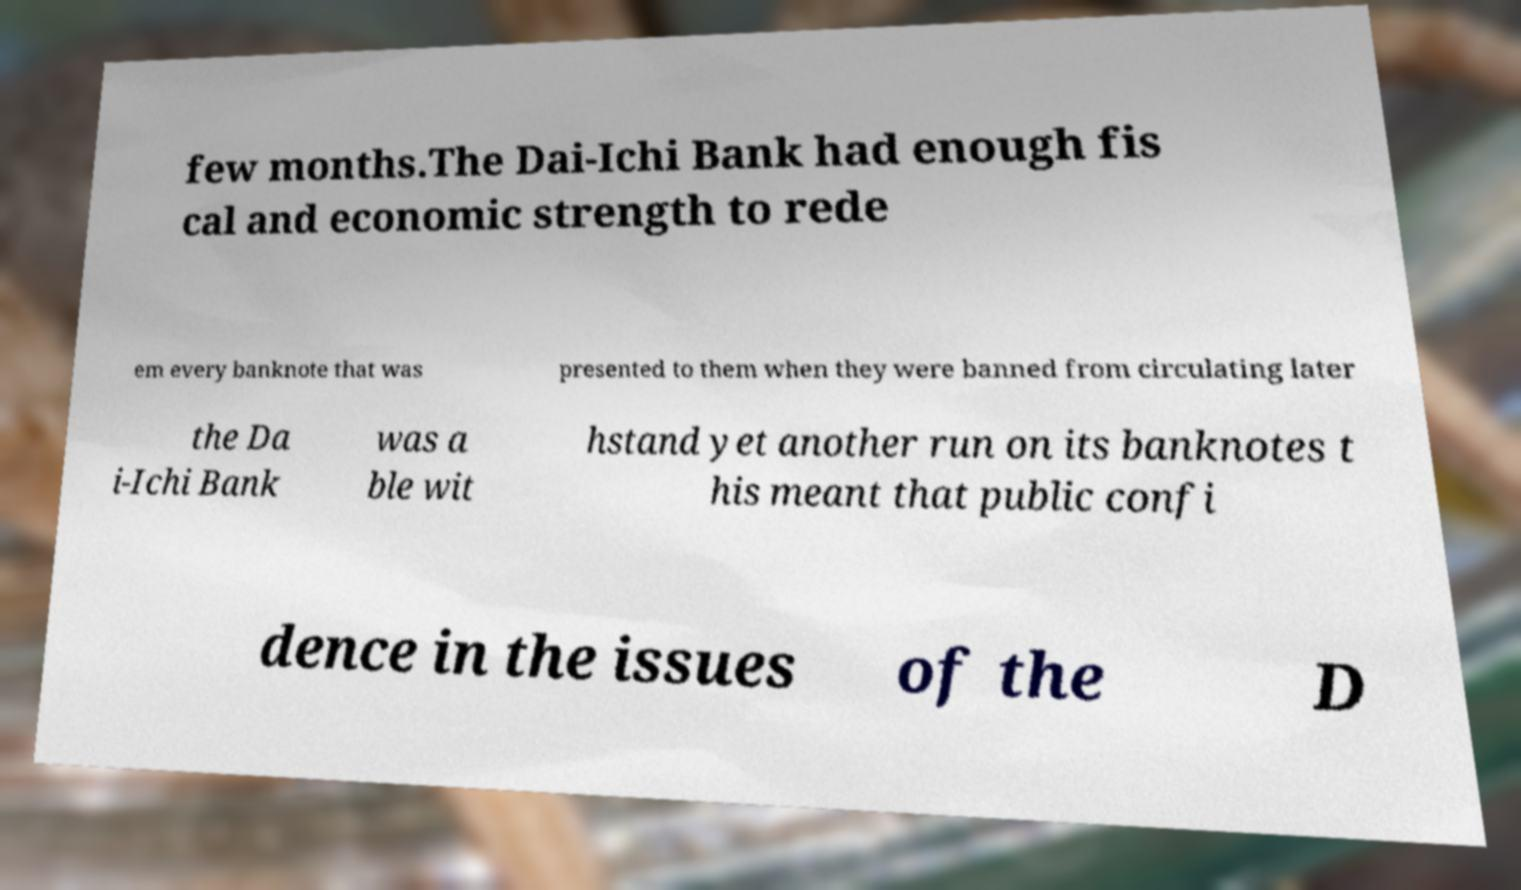For documentation purposes, I need the text within this image transcribed. Could you provide that? few months.The Dai-Ichi Bank had enough fis cal and economic strength to rede em every banknote that was presented to them when they were banned from circulating later the Da i-Ichi Bank was a ble wit hstand yet another run on its banknotes t his meant that public confi dence in the issues of the D 